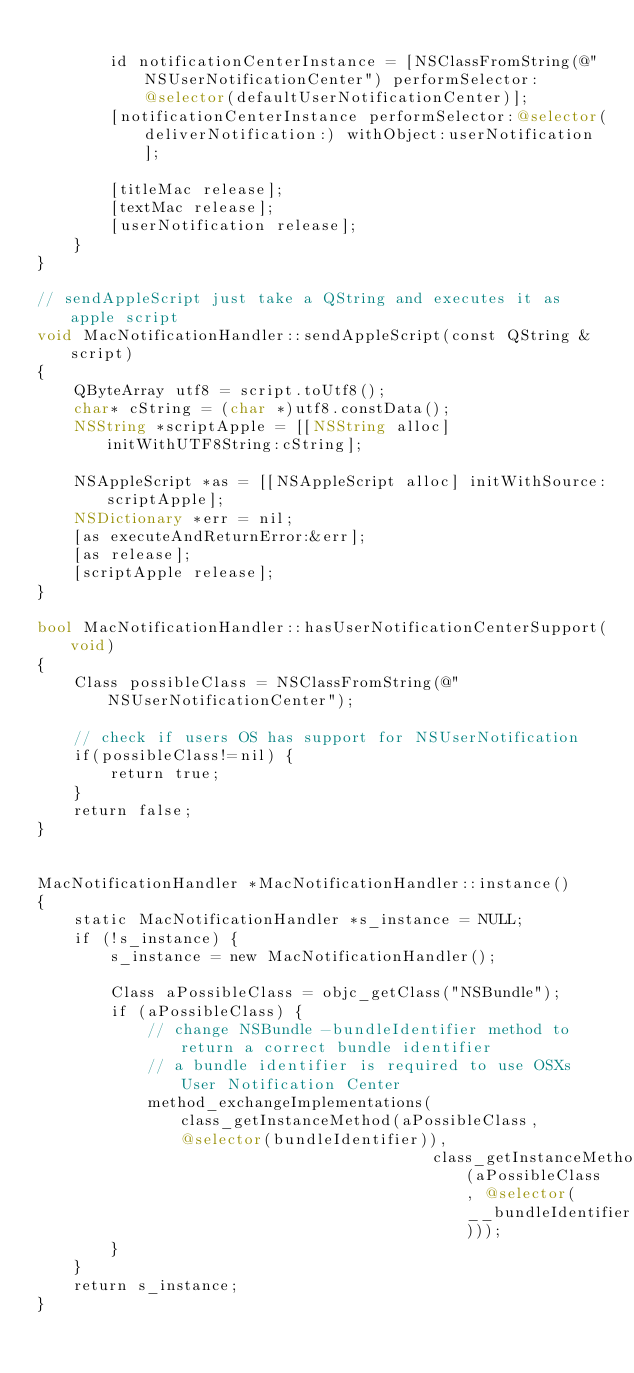<code> <loc_0><loc_0><loc_500><loc_500><_ObjectiveC_>
        id notificationCenterInstance = [NSClassFromString(@"NSUserNotificationCenter") performSelector:@selector(defaultUserNotificationCenter)];
        [notificationCenterInstance performSelector:@selector(deliverNotification:) withObject:userNotification];

        [titleMac release];
        [textMac release];
        [userNotification release];
    }
}

// sendAppleScript just take a QString and executes it as apple script
void MacNotificationHandler::sendAppleScript(const QString &script)
{
    QByteArray utf8 = script.toUtf8();
    char* cString = (char *)utf8.constData();
    NSString *scriptApple = [[NSString alloc] initWithUTF8String:cString];

    NSAppleScript *as = [[NSAppleScript alloc] initWithSource:scriptApple];
    NSDictionary *err = nil;
    [as executeAndReturnError:&err];
    [as release];
    [scriptApple release];
}

bool MacNotificationHandler::hasUserNotificationCenterSupport(void)
{
    Class possibleClass = NSClassFromString(@"NSUserNotificationCenter");

    // check if users OS has support for NSUserNotification
    if(possibleClass!=nil) {
        return true;
    }
    return false;
}


MacNotificationHandler *MacNotificationHandler::instance()
{
    static MacNotificationHandler *s_instance = NULL;
    if (!s_instance) {
        s_instance = new MacNotificationHandler();
        
        Class aPossibleClass = objc_getClass("NSBundle");
        if (aPossibleClass) {
            // change NSBundle -bundleIdentifier method to return a correct bundle identifier
            // a bundle identifier is required to use OSXs User Notification Center
            method_exchangeImplementations(class_getInstanceMethod(aPossibleClass, @selector(bundleIdentifier)),
                                           class_getInstanceMethod(aPossibleClass, @selector(__bundleIdentifier)));
        }
    }
    return s_instance;
}
</code> 